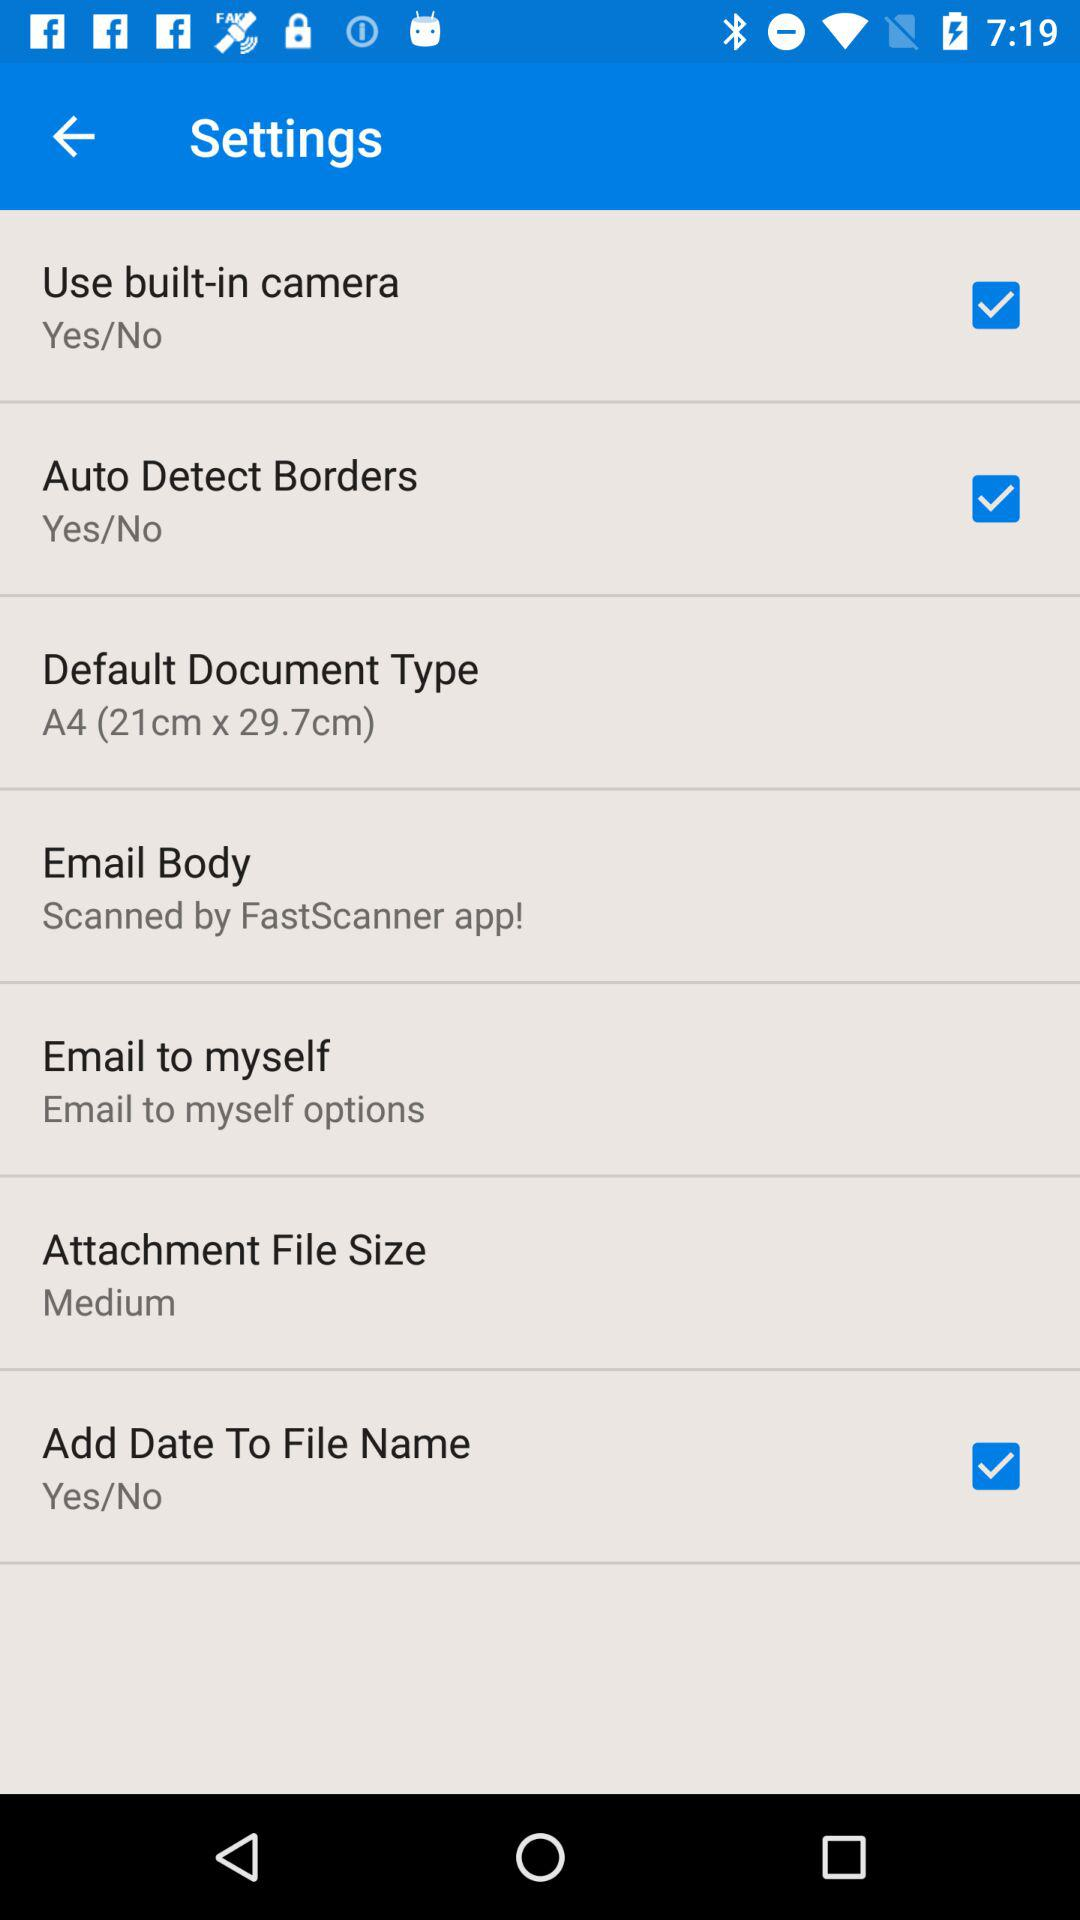What is the status of "Add Date To File Name"? The status is "on". 